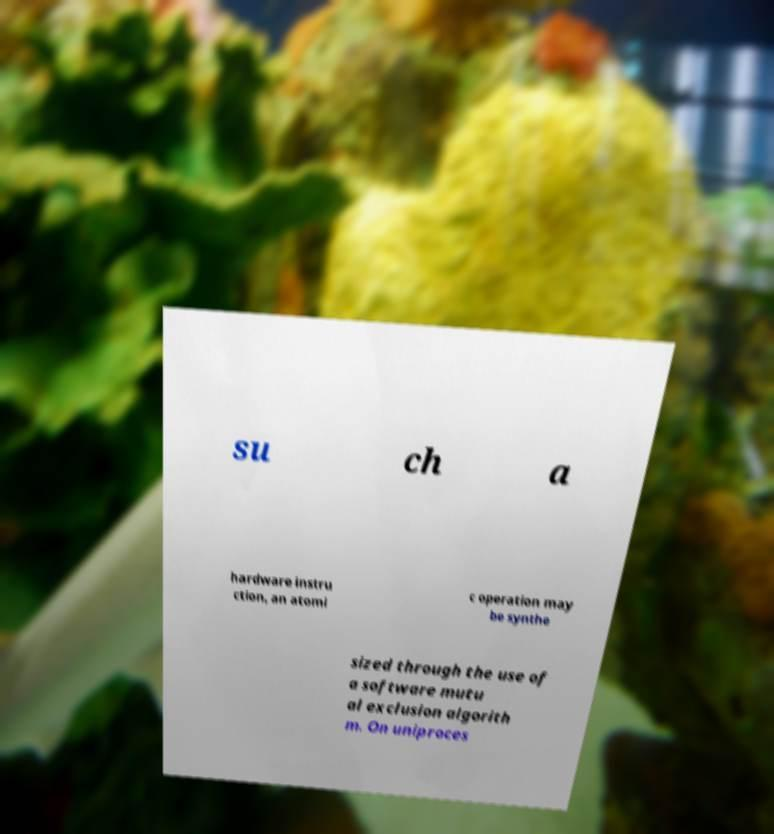I need the written content from this picture converted into text. Can you do that? su ch a hardware instru ction, an atomi c operation may be synthe sized through the use of a software mutu al exclusion algorith m. On uniproces 